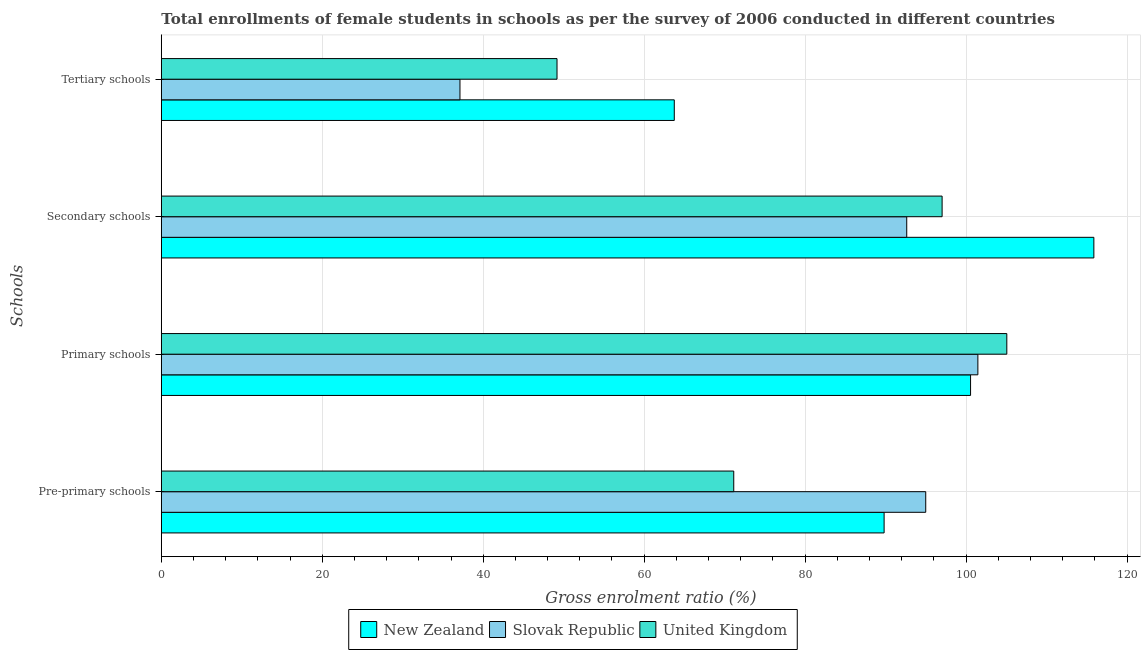How many different coloured bars are there?
Your answer should be compact. 3. How many groups of bars are there?
Your answer should be compact. 4. How many bars are there on the 4th tick from the bottom?
Ensure brevity in your answer.  3. What is the label of the 2nd group of bars from the top?
Your answer should be very brief. Secondary schools. What is the gross enrolment ratio(female) in secondary schools in New Zealand?
Offer a very short reply. 115.88. Across all countries, what is the maximum gross enrolment ratio(female) in pre-primary schools?
Your response must be concise. 94.99. Across all countries, what is the minimum gross enrolment ratio(female) in pre-primary schools?
Provide a short and direct response. 71.13. In which country was the gross enrolment ratio(female) in tertiary schools maximum?
Your answer should be very brief. New Zealand. In which country was the gross enrolment ratio(female) in pre-primary schools minimum?
Your response must be concise. United Kingdom. What is the total gross enrolment ratio(female) in secondary schools in the graph?
Your answer should be very brief. 305.53. What is the difference between the gross enrolment ratio(female) in primary schools in New Zealand and that in United Kingdom?
Give a very brief answer. -4.5. What is the difference between the gross enrolment ratio(female) in tertiary schools in United Kingdom and the gross enrolment ratio(female) in secondary schools in Slovak Republic?
Your answer should be compact. -43.46. What is the average gross enrolment ratio(female) in secondary schools per country?
Make the answer very short. 101.84. What is the difference between the gross enrolment ratio(female) in primary schools and gross enrolment ratio(female) in tertiary schools in Slovak Republic?
Give a very brief answer. 64.36. In how many countries, is the gross enrolment ratio(female) in pre-primary schools greater than 12 %?
Offer a very short reply. 3. What is the ratio of the gross enrolment ratio(female) in pre-primary schools in United Kingdom to that in New Zealand?
Your response must be concise. 0.79. Is the gross enrolment ratio(female) in secondary schools in United Kingdom less than that in New Zealand?
Provide a succinct answer. Yes. Is the difference between the gross enrolment ratio(female) in primary schools in Slovak Republic and New Zealand greater than the difference between the gross enrolment ratio(female) in secondary schools in Slovak Republic and New Zealand?
Provide a short and direct response. Yes. What is the difference between the highest and the second highest gross enrolment ratio(female) in primary schools?
Ensure brevity in your answer.  3.59. What is the difference between the highest and the lowest gross enrolment ratio(female) in primary schools?
Your response must be concise. 4.5. Is the sum of the gross enrolment ratio(female) in pre-primary schools in United Kingdom and Slovak Republic greater than the maximum gross enrolment ratio(female) in tertiary schools across all countries?
Ensure brevity in your answer.  Yes. What does the 3rd bar from the top in Tertiary schools represents?
Make the answer very short. New Zealand. What does the 3rd bar from the bottom in Tertiary schools represents?
Offer a very short reply. United Kingdom. Are all the bars in the graph horizontal?
Provide a short and direct response. Yes. How many countries are there in the graph?
Your response must be concise. 3. What is the title of the graph?
Provide a succinct answer. Total enrollments of female students in schools as per the survey of 2006 conducted in different countries. What is the label or title of the X-axis?
Your answer should be very brief. Gross enrolment ratio (%). What is the label or title of the Y-axis?
Keep it short and to the point. Schools. What is the Gross enrolment ratio (%) of New Zealand in Pre-primary schools?
Give a very brief answer. 89.82. What is the Gross enrolment ratio (%) of Slovak Republic in Pre-primary schools?
Make the answer very short. 94.99. What is the Gross enrolment ratio (%) of United Kingdom in Pre-primary schools?
Your answer should be compact. 71.13. What is the Gross enrolment ratio (%) of New Zealand in Primary schools?
Offer a very short reply. 100.56. What is the Gross enrolment ratio (%) in Slovak Republic in Primary schools?
Provide a short and direct response. 101.47. What is the Gross enrolment ratio (%) of United Kingdom in Primary schools?
Ensure brevity in your answer.  105.06. What is the Gross enrolment ratio (%) in New Zealand in Secondary schools?
Offer a terse response. 115.88. What is the Gross enrolment ratio (%) of Slovak Republic in Secondary schools?
Offer a very short reply. 92.63. What is the Gross enrolment ratio (%) of United Kingdom in Secondary schools?
Provide a succinct answer. 97.02. What is the Gross enrolment ratio (%) in New Zealand in Tertiary schools?
Offer a very short reply. 63.74. What is the Gross enrolment ratio (%) in Slovak Republic in Tertiary schools?
Offer a very short reply. 37.11. What is the Gross enrolment ratio (%) in United Kingdom in Tertiary schools?
Make the answer very short. 49.17. Across all Schools, what is the maximum Gross enrolment ratio (%) of New Zealand?
Provide a succinct answer. 115.88. Across all Schools, what is the maximum Gross enrolment ratio (%) of Slovak Republic?
Provide a succinct answer. 101.47. Across all Schools, what is the maximum Gross enrolment ratio (%) in United Kingdom?
Your response must be concise. 105.06. Across all Schools, what is the minimum Gross enrolment ratio (%) of New Zealand?
Your response must be concise. 63.74. Across all Schools, what is the minimum Gross enrolment ratio (%) of Slovak Republic?
Your response must be concise. 37.11. Across all Schools, what is the minimum Gross enrolment ratio (%) of United Kingdom?
Your answer should be very brief. 49.17. What is the total Gross enrolment ratio (%) of New Zealand in the graph?
Offer a terse response. 370. What is the total Gross enrolment ratio (%) of Slovak Republic in the graph?
Your answer should be very brief. 326.2. What is the total Gross enrolment ratio (%) in United Kingdom in the graph?
Give a very brief answer. 322.39. What is the difference between the Gross enrolment ratio (%) in New Zealand in Pre-primary schools and that in Primary schools?
Offer a terse response. -10.74. What is the difference between the Gross enrolment ratio (%) in Slovak Republic in Pre-primary schools and that in Primary schools?
Your response must be concise. -6.48. What is the difference between the Gross enrolment ratio (%) of United Kingdom in Pre-primary schools and that in Primary schools?
Provide a succinct answer. -33.93. What is the difference between the Gross enrolment ratio (%) of New Zealand in Pre-primary schools and that in Secondary schools?
Offer a very short reply. -26.07. What is the difference between the Gross enrolment ratio (%) in Slovak Republic in Pre-primary schools and that in Secondary schools?
Provide a short and direct response. 2.36. What is the difference between the Gross enrolment ratio (%) in United Kingdom in Pre-primary schools and that in Secondary schools?
Give a very brief answer. -25.89. What is the difference between the Gross enrolment ratio (%) in New Zealand in Pre-primary schools and that in Tertiary schools?
Your answer should be compact. 26.07. What is the difference between the Gross enrolment ratio (%) in Slovak Republic in Pre-primary schools and that in Tertiary schools?
Offer a very short reply. 57.88. What is the difference between the Gross enrolment ratio (%) in United Kingdom in Pre-primary schools and that in Tertiary schools?
Provide a short and direct response. 21.96. What is the difference between the Gross enrolment ratio (%) of New Zealand in Primary schools and that in Secondary schools?
Ensure brevity in your answer.  -15.32. What is the difference between the Gross enrolment ratio (%) of Slovak Republic in Primary schools and that in Secondary schools?
Provide a short and direct response. 8.84. What is the difference between the Gross enrolment ratio (%) of United Kingdom in Primary schools and that in Secondary schools?
Keep it short and to the point. 8.04. What is the difference between the Gross enrolment ratio (%) in New Zealand in Primary schools and that in Tertiary schools?
Make the answer very short. 36.82. What is the difference between the Gross enrolment ratio (%) in Slovak Republic in Primary schools and that in Tertiary schools?
Offer a terse response. 64.36. What is the difference between the Gross enrolment ratio (%) in United Kingdom in Primary schools and that in Tertiary schools?
Give a very brief answer. 55.89. What is the difference between the Gross enrolment ratio (%) of New Zealand in Secondary schools and that in Tertiary schools?
Keep it short and to the point. 52.14. What is the difference between the Gross enrolment ratio (%) of Slovak Republic in Secondary schools and that in Tertiary schools?
Your response must be concise. 55.52. What is the difference between the Gross enrolment ratio (%) of United Kingdom in Secondary schools and that in Tertiary schools?
Give a very brief answer. 47.85. What is the difference between the Gross enrolment ratio (%) in New Zealand in Pre-primary schools and the Gross enrolment ratio (%) in Slovak Republic in Primary schools?
Give a very brief answer. -11.65. What is the difference between the Gross enrolment ratio (%) of New Zealand in Pre-primary schools and the Gross enrolment ratio (%) of United Kingdom in Primary schools?
Make the answer very short. -15.25. What is the difference between the Gross enrolment ratio (%) of Slovak Republic in Pre-primary schools and the Gross enrolment ratio (%) of United Kingdom in Primary schools?
Your answer should be compact. -10.07. What is the difference between the Gross enrolment ratio (%) in New Zealand in Pre-primary schools and the Gross enrolment ratio (%) in Slovak Republic in Secondary schools?
Give a very brief answer. -2.81. What is the difference between the Gross enrolment ratio (%) of New Zealand in Pre-primary schools and the Gross enrolment ratio (%) of United Kingdom in Secondary schools?
Your answer should be compact. -7.21. What is the difference between the Gross enrolment ratio (%) of Slovak Republic in Pre-primary schools and the Gross enrolment ratio (%) of United Kingdom in Secondary schools?
Ensure brevity in your answer.  -2.03. What is the difference between the Gross enrolment ratio (%) in New Zealand in Pre-primary schools and the Gross enrolment ratio (%) in Slovak Republic in Tertiary schools?
Provide a succinct answer. 52.7. What is the difference between the Gross enrolment ratio (%) in New Zealand in Pre-primary schools and the Gross enrolment ratio (%) in United Kingdom in Tertiary schools?
Ensure brevity in your answer.  40.65. What is the difference between the Gross enrolment ratio (%) in Slovak Republic in Pre-primary schools and the Gross enrolment ratio (%) in United Kingdom in Tertiary schools?
Ensure brevity in your answer.  45.82. What is the difference between the Gross enrolment ratio (%) in New Zealand in Primary schools and the Gross enrolment ratio (%) in Slovak Republic in Secondary schools?
Your answer should be compact. 7.93. What is the difference between the Gross enrolment ratio (%) in New Zealand in Primary schools and the Gross enrolment ratio (%) in United Kingdom in Secondary schools?
Give a very brief answer. 3.54. What is the difference between the Gross enrolment ratio (%) in Slovak Republic in Primary schools and the Gross enrolment ratio (%) in United Kingdom in Secondary schools?
Your response must be concise. 4.45. What is the difference between the Gross enrolment ratio (%) of New Zealand in Primary schools and the Gross enrolment ratio (%) of Slovak Republic in Tertiary schools?
Provide a short and direct response. 63.45. What is the difference between the Gross enrolment ratio (%) of New Zealand in Primary schools and the Gross enrolment ratio (%) of United Kingdom in Tertiary schools?
Provide a short and direct response. 51.39. What is the difference between the Gross enrolment ratio (%) of Slovak Republic in Primary schools and the Gross enrolment ratio (%) of United Kingdom in Tertiary schools?
Offer a very short reply. 52.3. What is the difference between the Gross enrolment ratio (%) in New Zealand in Secondary schools and the Gross enrolment ratio (%) in Slovak Republic in Tertiary schools?
Provide a succinct answer. 78.77. What is the difference between the Gross enrolment ratio (%) in New Zealand in Secondary schools and the Gross enrolment ratio (%) in United Kingdom in Tertiary schools?
Ensure brevity in your answer.  66.71. What is the difference between the Gross enrolment ratio (%) in Slovak Republic in Secondary schools and the Gross enrolment ratio (%) in United Kingdom in Tertiary schools?
Offer a terse response. 43.46. What is the average Gross enrolment ratio (%) in New Zealand per Schools?
Your answer should be compact. 92.5. What is the average Gross enrolment ratio (%) in Slovak Republic per Schools?
Keep it short and to the point. 81.55. What is the average Gross enrolment ratio (%) in United Kingdom per Schools?
Your response must be concise. 80.6. What is the difference between the Gross enrolment ratio (%) in New Zealand and Gross enrolment ratio (%) in Slovak Republic in Pre-primary schools?
Your answer should be very brief. -5.17. What is the difference between the Gross enrolment ratio (%) in New Zealand and Gross enrolment ratio (%) in United Kingdom in Pre-primary schools?
Your answer should be compact. 18.68. What is the difference between the Gross enrolment ratio (%) of Slovak Republic and Gross enrolment ratio (%) of United Kingdom in Pre-primary schools?
Make the answer very short. 23.86. What is the difference between the Gross enrolment ratio (%) in New Zealand and Gross enrolment ratio (%) in Slovak Republic in Primary schools?
Provide a short and direct response. -0.91. What is the difference between the Gross enrolment ratio (%) in New Zealand and Gross enrolment ratio (%) in United Kingdom in Primary schools?
Make the answer very short. -4.5. What is the difference between the Gross enrolment ratio (%) of Slovak Republic and Gross enrolment ratio (%) of United Kingdom in Primary schools?
Your answer should be very brief. -3.59. What is the difference between the Gross enrolment ratio (%) in New Zealand and Gross enrolment ratio (%) in Slovak Republic in Secondary schools?
Provide a succinct answer. 23.25. What is the difference between the Gross enrolment ratio (%) of New Zealand and Gross enrolment ratio (%) of United Kingdom in Secondary schools?
Ensure brevity in your answer.  18.86. What is the difference between the Gross enrolment ratio (%) of Slovak Republic and Gross enrolment ratio (%) of United Kingdom in Secondary schools?
Your response must be concise. -4.39. What is the difference between the Gross enrolment ratio (%) in New Zealand and Gross enrolment ratio (%) in Slovak Republic in Tertiary schools?
Ensure brevity in your answer.  26.63. What is the difference between the Gross enrolment ratio (%) in New Zealand and Gross enrolment ratio (%) in United Kingdom in Tertiary schools?
Offer a very short reply. 14.57. What is the difference between the Gross enrolment ratio (%) in Slovak Republic and Gross enrolment ratio (%) in United Kingdom in Tertiary schools?
Offer a very short reply. -12.06. What is the ratio of the Gross enrolment ratio (%) of New Zealand in Pre-primary schools to that in Primary schools?
Your answer should be compact. 0.89. What is the ratio of the Gross enrolment ratio (%) in Slovak Republic in Pre-primary schools to that in Primary schools?
Provide a succinct answer. 0.94. What is the ratio of the Gross enrolment ratio (%) of United Kingdom in Pre-primary schools to that in Primary schools?
Make the answer very short. 0.68. What is the ratio of the Gross enrolment ratio (%) of New Zealand in Pre-primary schools to that in Secondary schools?
Give a very brief answer. 0.78. What is the ratio of the Gross enrolment ratio (%) of Slovak Republic in Pre-primary schools to that in Secondary schools?
Your answer should be very brief. 1.03. What is the ratio of the Gross enrolment ratio (%) in United Kingdom in Pre-primary schools to that in Secondary schools?
Your answer should be compact. 0.73. What is the ratio of the Gross enrolment ratio (%) in New Zealand in Pre-primary schools to that in Tertiary schools?
Keep it short and to the point. 1.41. What is the ratio of the Gross enrolment ratio (%) of Slovak Republic in Pre-primary schools to that in Tertiary schools?
Your answer should be very brief. 2.56. What is the ratio of the Gross enrolment ratio (%) in United Kingdom in Pre-primary schools to that in Tertiary schools?
Your answer should be compact. 1.45. What is the ratio of the Gross enrolment ratio (%) of New Zealand in Primary schools to that in Secondary schools?
Keep it short and to the point. 0.87. What is the ratio of the Gross enrolment ratio (%) of Slovak Republic in Primary schools to that in Secondary schools?
Offer a terse response. 1.1. What is the ratio of the Gross enrolment ratio (%) in United Kingdom in Primary schools to that in Secondary schools?
Offer a very short reply. 1.08. What is the ratio of the Gross enrolment ratio (%) in New Zealand in Primary schools to that in Tertiary schools?
Offer a terse response. 1.58. What is the ratio of the Gross enrolment ratio (%) of Slovak Republic in Primary schools to that in Tertiary schools?
Your answer should be compact. 2.73. What is the ratio of the Gross enrolment ratio (%) in United Kingdom in Primary schools to that in Tertiary schools?
Keep it short and to the point. 2.14. What is the ratio of the Gross enrolment ratio (%) in New Zealand in Secondary schools to that in Tertiary schools?
Your response must be concise. 1.82. What is the ratio of the Gross enrolment ratio (%) in Slovak Republic in Secondary schools to that in Tertiary schools?
Keep it short and to the point. 2.5. What is the ratio of the Gross enrolment ratio (%) in United Kingdom in Secondary schools to that in Tertiary schools?
Give a very brief answer. 1.97. What is the difference between the highest and the second highest Gross enrolment ratio (%) of New Zealand?
Offer a very short reply. 15.32. What is the difference between the highest and the second highest Gross enrolment ratio (%) in Slovak Republic?
Keep it short and to the point. 6.48. What is the difference between the highest and the second highest Gross enrolment ratio (%) in United Kingdom?
Your response must be concise. 8.04. What is the difference between the highest and the lowest Gross enrolment ratio (%) of New Zealand?
Provide a short and direct response. 52.14. What is the difference between the highest and the lowest Gross enrolment ratio (%) of Slovak Republic?
Offer a very short reply. 64.36. What is the difference between the highest and the lowest Gross enrolment ratio (%) of United Kingdom?
Offer a terse response. 55.89. 